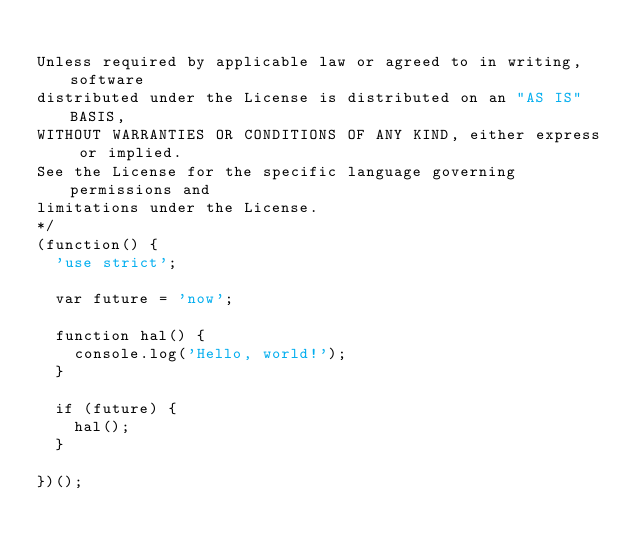<code> <loc_0><loc_0><loc_500><loc_500><_JavaScript_>
Unless required by applicable law or agreed to in writing, software
distributed under the License is distributed on an "AS IS" BASIS,
WITHOUT WARRANTIES OR CONDITIONS OF ANY KIND, either express or implied.
See the License for the specific language governing permissions and
limitations under the License.
*/
(function() {
  'use strict';

  var future = 'now';

  function hal() {
    console.log('Hello, world!');
  }

  if (future) {
    hal();
  }

})();
</code> 